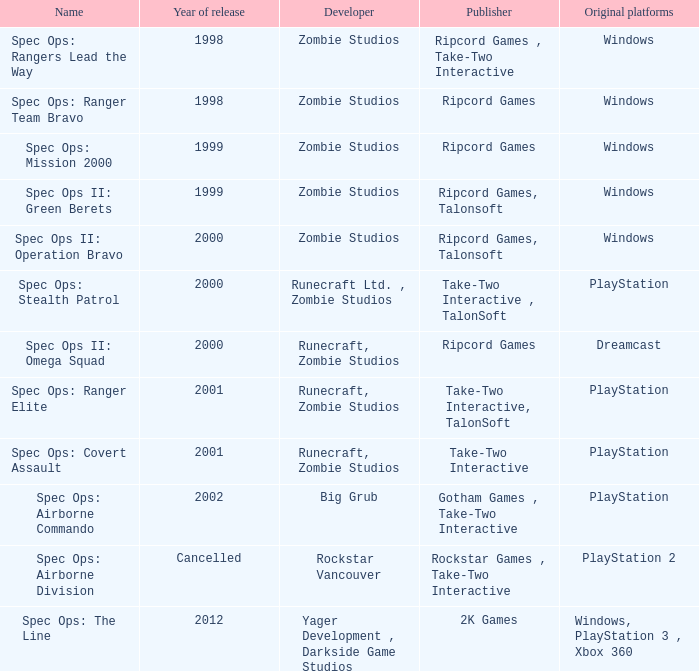Which publisher is responsible for spec ops: stealth patrol? Take-Two Interactive , TalonSoft. 